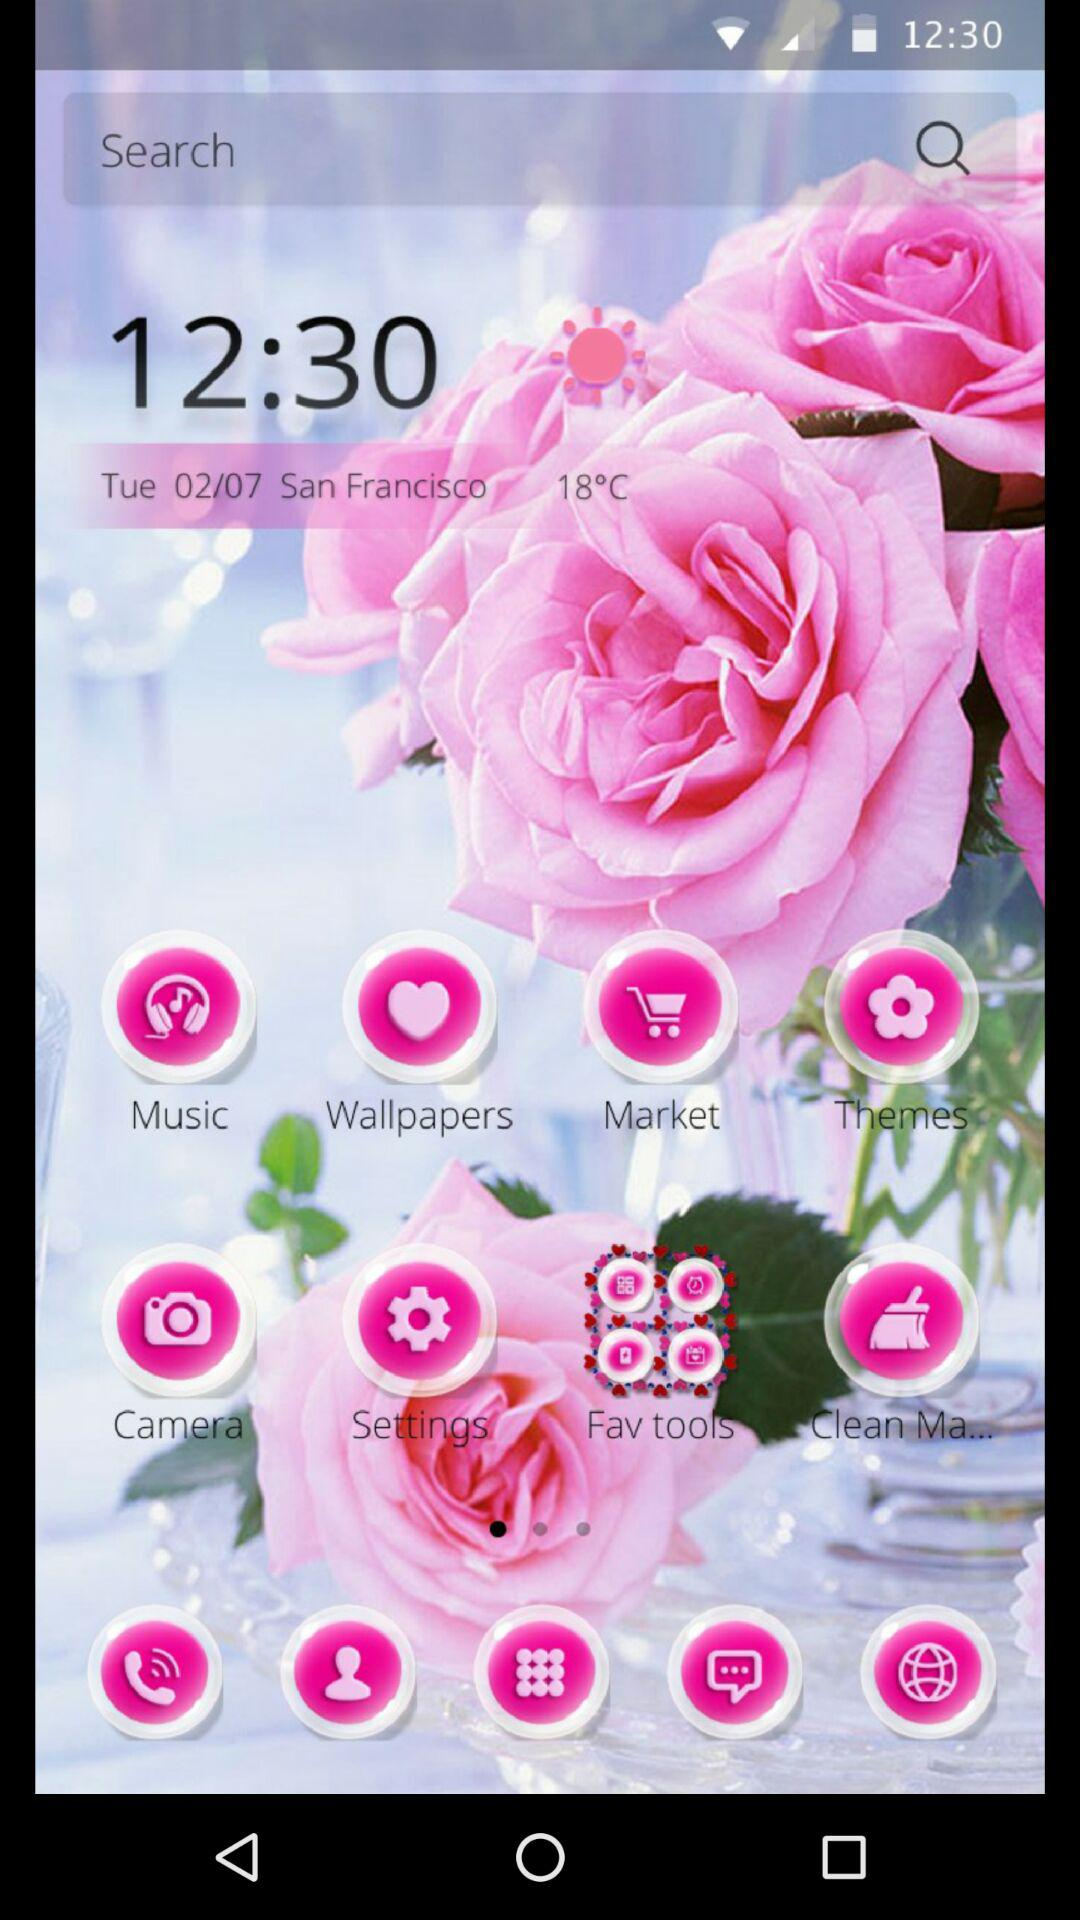What is the date? The date is Tuesday, February 7. 